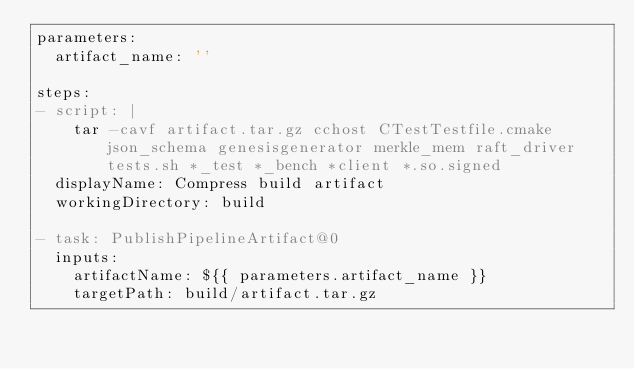Convert code to text. <code><loc_0><loc_0><loc_500><loc_500><_YAML_>parameters:
  artifact_name: ''

steps:
- script: |
    tar -cavf artifact.tar.gz cchost CTestTestfile.cmake json_schema genesisgenerator merkle_mem raft_driver tests.sh *_test *_bench *client *.so.signed
  displayName: Compress build artifact
  workingDirectory: build

- task: PublishPipelineArtifact@0
  inputs:
    artifactName: ${{ parameters.artifact_name }}
    targetPath: build/artifact.tar.gz
</code> 